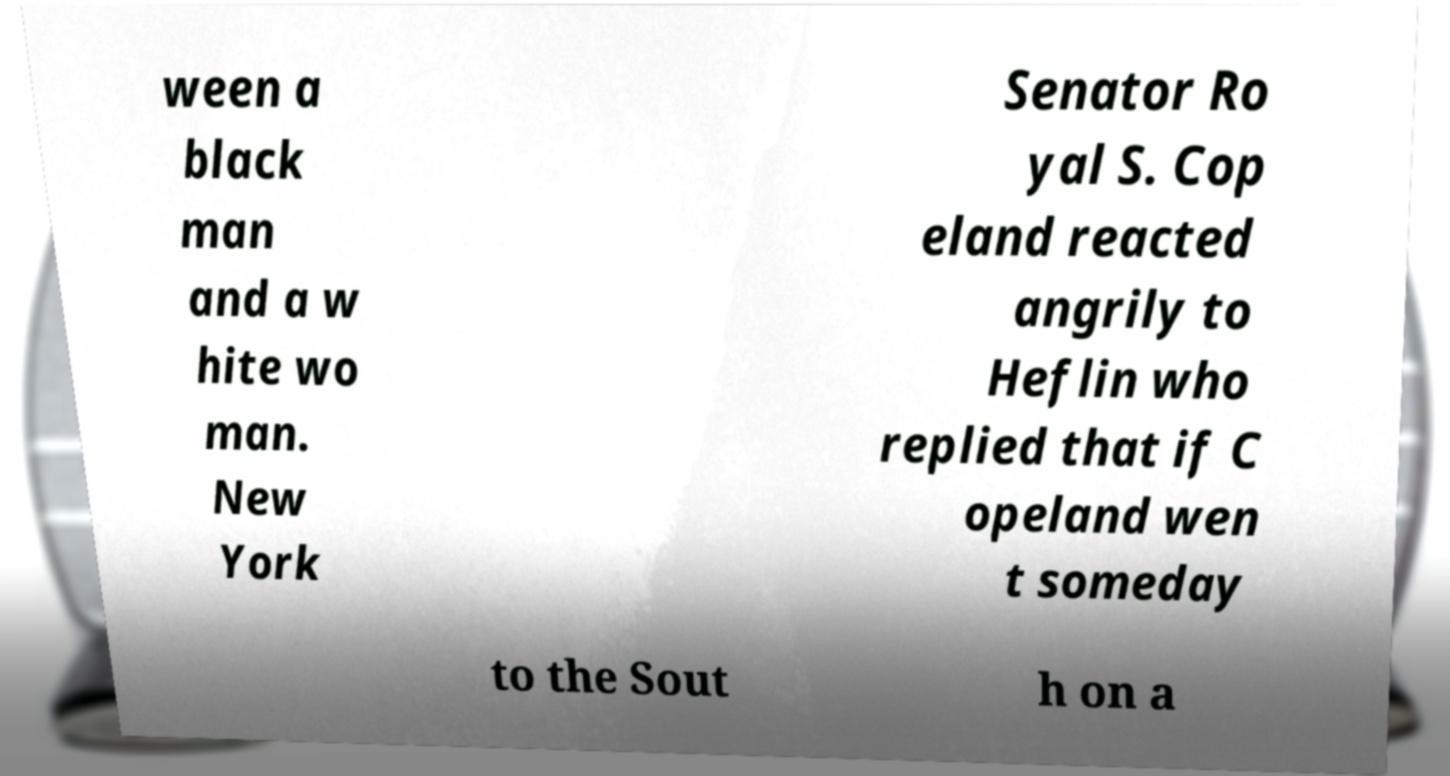I need the written content from this picture converted into text. Can you do that? ween a black man and a w hite wo man. New York Senator Ro yal S. Cop eland reacted angrily to Heflin who replied that if C opeland wen t someday to the Sout h on a 